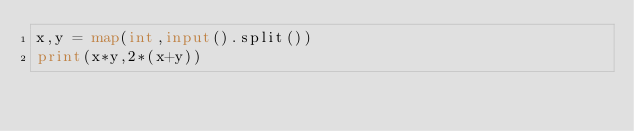Convert code to text. <code><loc_0><loc_0><loc_500><loc_500><_Python_>x,y = map(int,input().split())
print(x*y,2*(x+y))</code> 